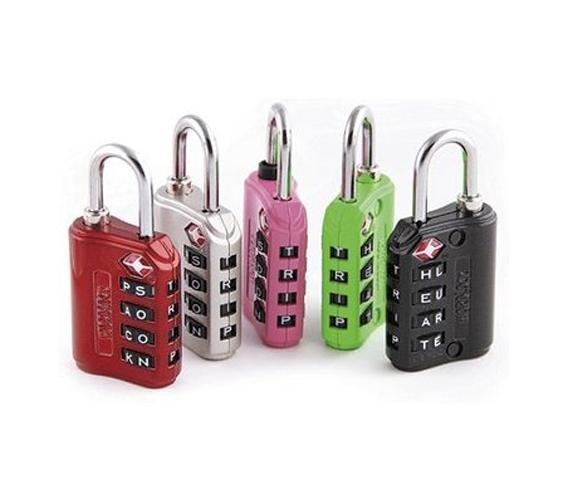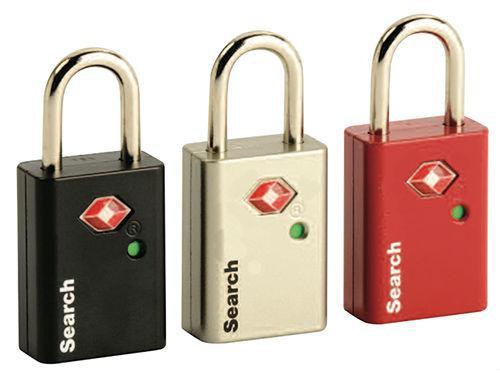The first image is the image on the left, the second image is the image on the right. Analyze the images presented: Is the assertion "there is no more then two locks in the right side image" valid? Answer yes or no. No. The first image is the image on the left, the second image is the image on the right. Evaluate the accuracy of this statement regarding the images: "One image has items other than one or more locks.". Is it true? Answer yes or no. No. 